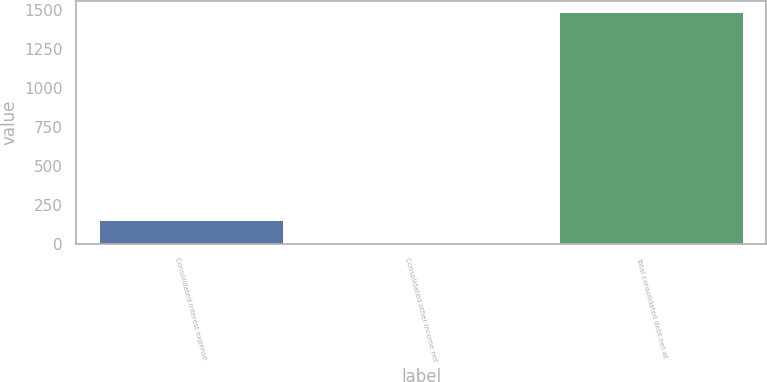<chart> <loc_0><loc_0><loc_500><loc_500><bar_chart><fcel>Consolidated interest expense<fcel>Consolidated other income net<fcel>Total consolidated debt net at<nl><fcel>152.14<fcel>4.1<fcel>1484.5<nl></chart> 